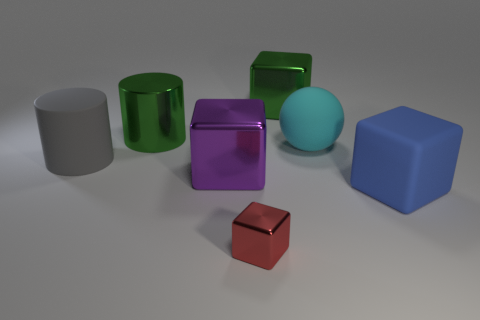There is a green thing left of the metal object that is in front of the matte cube; what is its material?
Keep it short and to the point. Metal. How many other blue matte things are the same shape as the blue matte thing?
Your answer should be compact. 0. Are there any shiny blocks that have the same color as the small metallic thing?
Give a very brief answer. No. What number of objects are large green blocks behind the rubber cylinder or metallic cubes that are behind the sphere?
Keep it short and to the point. 1. There is a large thing that is in front of the purple cube; are there any small objects that are on the right side of it?
Give a very brief answer. No. What shape is the cyan object that is the same size as the green cylinder?
Your response must be concise. Sphere. How many objects are either large cubes that are left of the red metal object or blue metallic cylinders?
Ensure brevity in your answer.  1. How many other things are the same material as the large sphere?
Make the answer very short. 2. What shape is the metallic object that is the same color as the shiny cylinder?
Provide a short and direct response. Cube. What size is the metal block to the left of the tiny cube?
Your answer should be very brief. Large. 